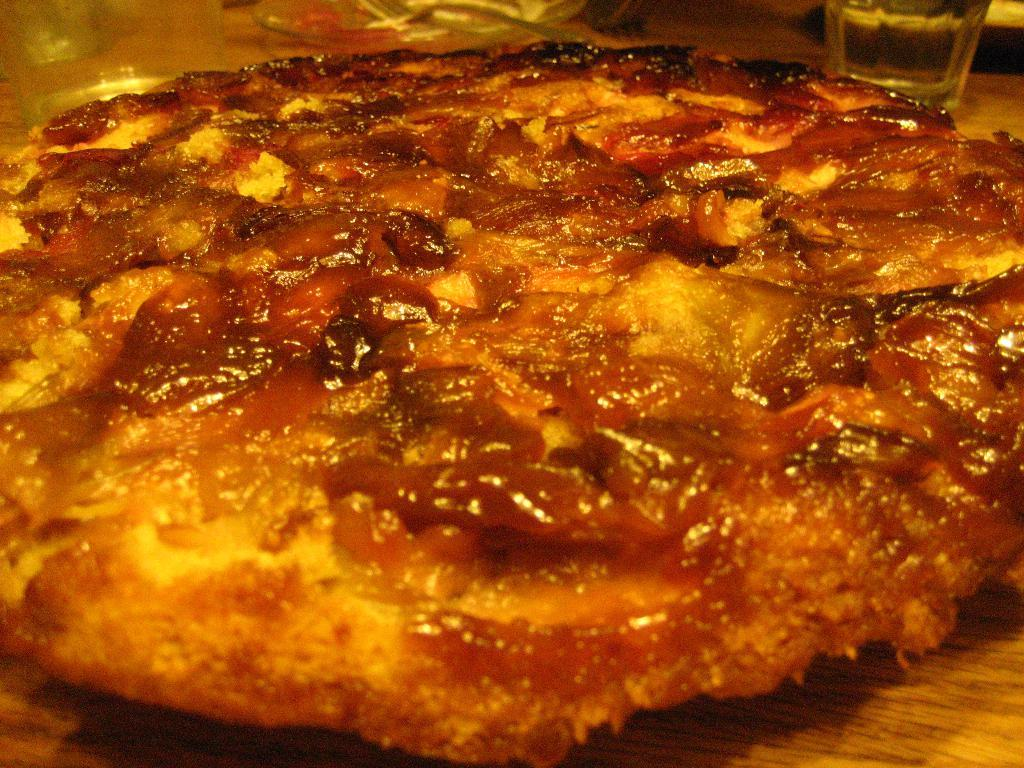What objects are on the wooden surface in the image? There are glasses, a fork, and a plate on the wooden surface. What else can be seen on the wooden surface? There is food on the wooden surface. What type of pipe is visible in the image? There is no pipe present in the image. How does the brake function in the image? There is no brake present in the image. 